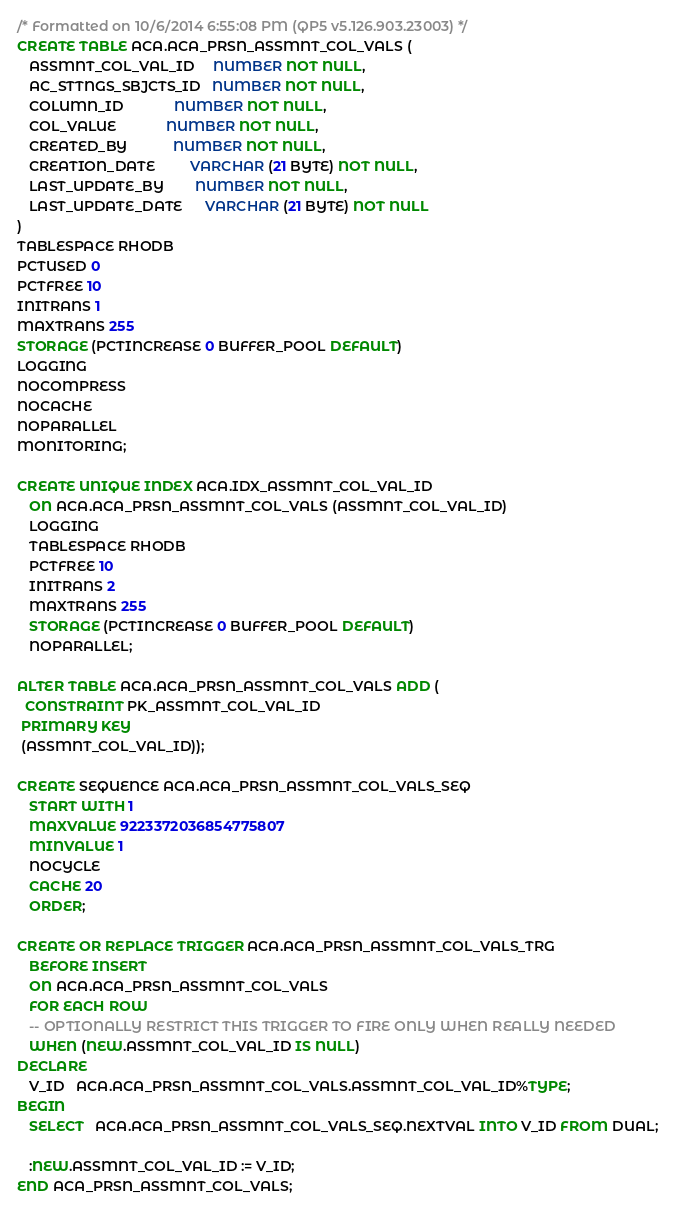<code> <loc_0><loc_0><loc_500><loc_500><_SQL_>/* Formatted on 10/6/2014 6:55:08 PM (QP5 v5.126.903.23003) */
CREATE TABLE ACA.ACA_PRSN_ASSMNT_COL_VALS (
   ASSMNT_COL_VAL_ID     NUMBER NOT NULL,
   AC_STTNGS_SBJCTS_ID   NUMBER NOT NULL,
   COLUMN_ID             NUMBER NOT NULL,
   COL_VALUE             NUMBER NOT NULL,
   CREATED_BY            NUMBER NOT NULL,
   CREATION_DATE         VARCHAR (21 BYTE) NOT NULL,
   LAST_UPDATE_BY        NUMBER NOT NULL,
   LAST_UPDATE_DATE      VARCHAR (21 BYTE) NOT NULL
)
TABLESPACE RHODB
PCTUSED 0
PCTFREE 10
INITRANS 1
MAXTRANS 255
STORAGE (PCTINCREASE 0 BUFFER_POOL DEFAULT)
LOGGING
NOCOMPRESS
NOCACHE
NOPARALLEL
MONITORING;

CREATE UNIQUE INDEX ACA.IDX_ASSMNT_COL_VAL_ID
   ON ACA.ACA_PRSN_ASSMNT_COL_VALS (ASSMNT_COL_VAL_ID)
   LOGGING
   TABLESPACE RHODB
   PCTFREE 10
   INITRANS 2
   MAXTRANS 255
   STORAGE (PCTINCREASE 0 BUFFER_POOL DEFAULT)
   NOPARALLEL;

ALTER TABLE ACA.ACA_PRSN_ASSMNT_COL_VALS ADD (
  CONSTRAINT PK_ASSMNT_COL_VAL_ID
 PRIMARY KEY
 (ASSMNT_COL_VAL_ID));

CREATE SEQUENCE ACA.ACA_PRSN_ASSMNT_COL_VALS_SEQ
   START WITH 1
   MAXVALUE 9223372036854775807
   MINVALUE 1
   NOCYCLE
   CACHE 20
   ORDER;

CREATE OR REPLACE TRIGGER ACA.ACA_PRSN_ASSMNT_COL_VALS_TRG
   BEFORE INSERT
   ON ACA.ACA_PRSN_ASSMNT_COL_VALS
   FOR EACH ROW
   -- OPTIONALLY RESTRICT THIS TRIGGER TO FIRE ONLY WHEN REALLY NEEDED
   WHEN (NEW.ASSMNT_COL_VAL_ID IS NULL)
DECLARE
   V_ID   ACA.ACA_PRSN_ASSMNT_COL_VALS.ASSMNT_COL_VAL_ID%TYPE;
BEGIN
   SELECT   ACA.ACA_PRSN_ASSMNT_COL_VALS_SEQ.NEXTVAL INTO V_ID FROM DUAL;

   :NEW.ASSMNT_COL_VAL_ID := V_ID;
END ACA_PRSN_ASSMNT_COL_VALS;</code> 